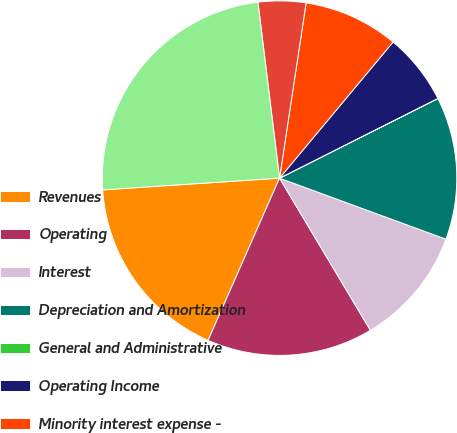<chart> <loc_0><loc_0><loc_500><loc_500><pie_chart><fcel>Revenues<fcel>Operating<fcel>Interest<fcel>Depreciation and Amortization<fcel>General and Administrative<fcel>Operating Income<fcel>Minority interest expense -<fcel>Net income from discontinued<fcel>Gain (loss) on sale of<nl><fcel>17.34%<fcel>15.17%<fcel>10.84%<fcel>13.01%<fcel>0.01%<fcel>6.51%<fcel>8.67%<fcel>4.34%<fcel>24.11%<nl></chart> 